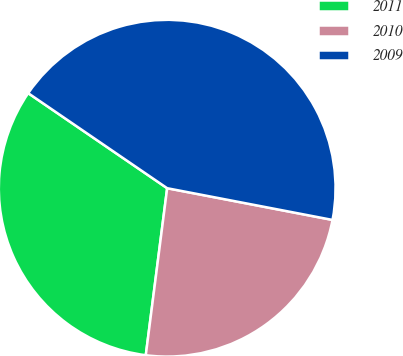Convert chart. <chart><loc_0><loc_0><loc_500><loc_500><pie_chart><fcel>2011<fcel>2010<fcel>2009<nl><fcel>32.52%<fcel>24.01%<fcel>43.47%<nl></chart> 